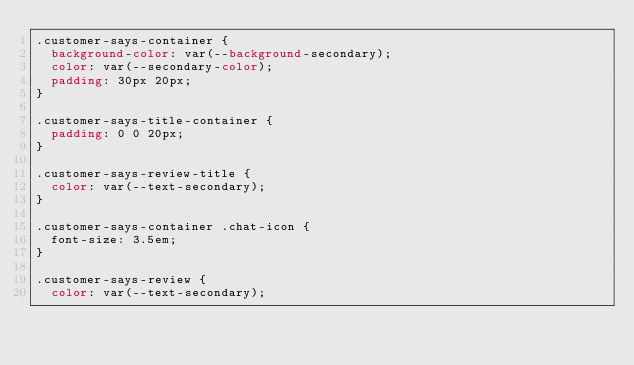Convert code to text. <code><loc_0><loc_0><loc_500><loc_500><_CSS_>.customer-says-container {
  background-color: var(--background-secondary);
  color: var(--secondary-color);
  padding: 30px 20px;
}

.customer-says-title-container {
  padding: 0 0 20px;
}

.customer-says-review-title {
  color: var(--text-secondary);
}

.customer-says-container .chat-icon {
  font-size: 3.5em;
}

.customer-says-review {
  color: var(--text-secondary);</code> 